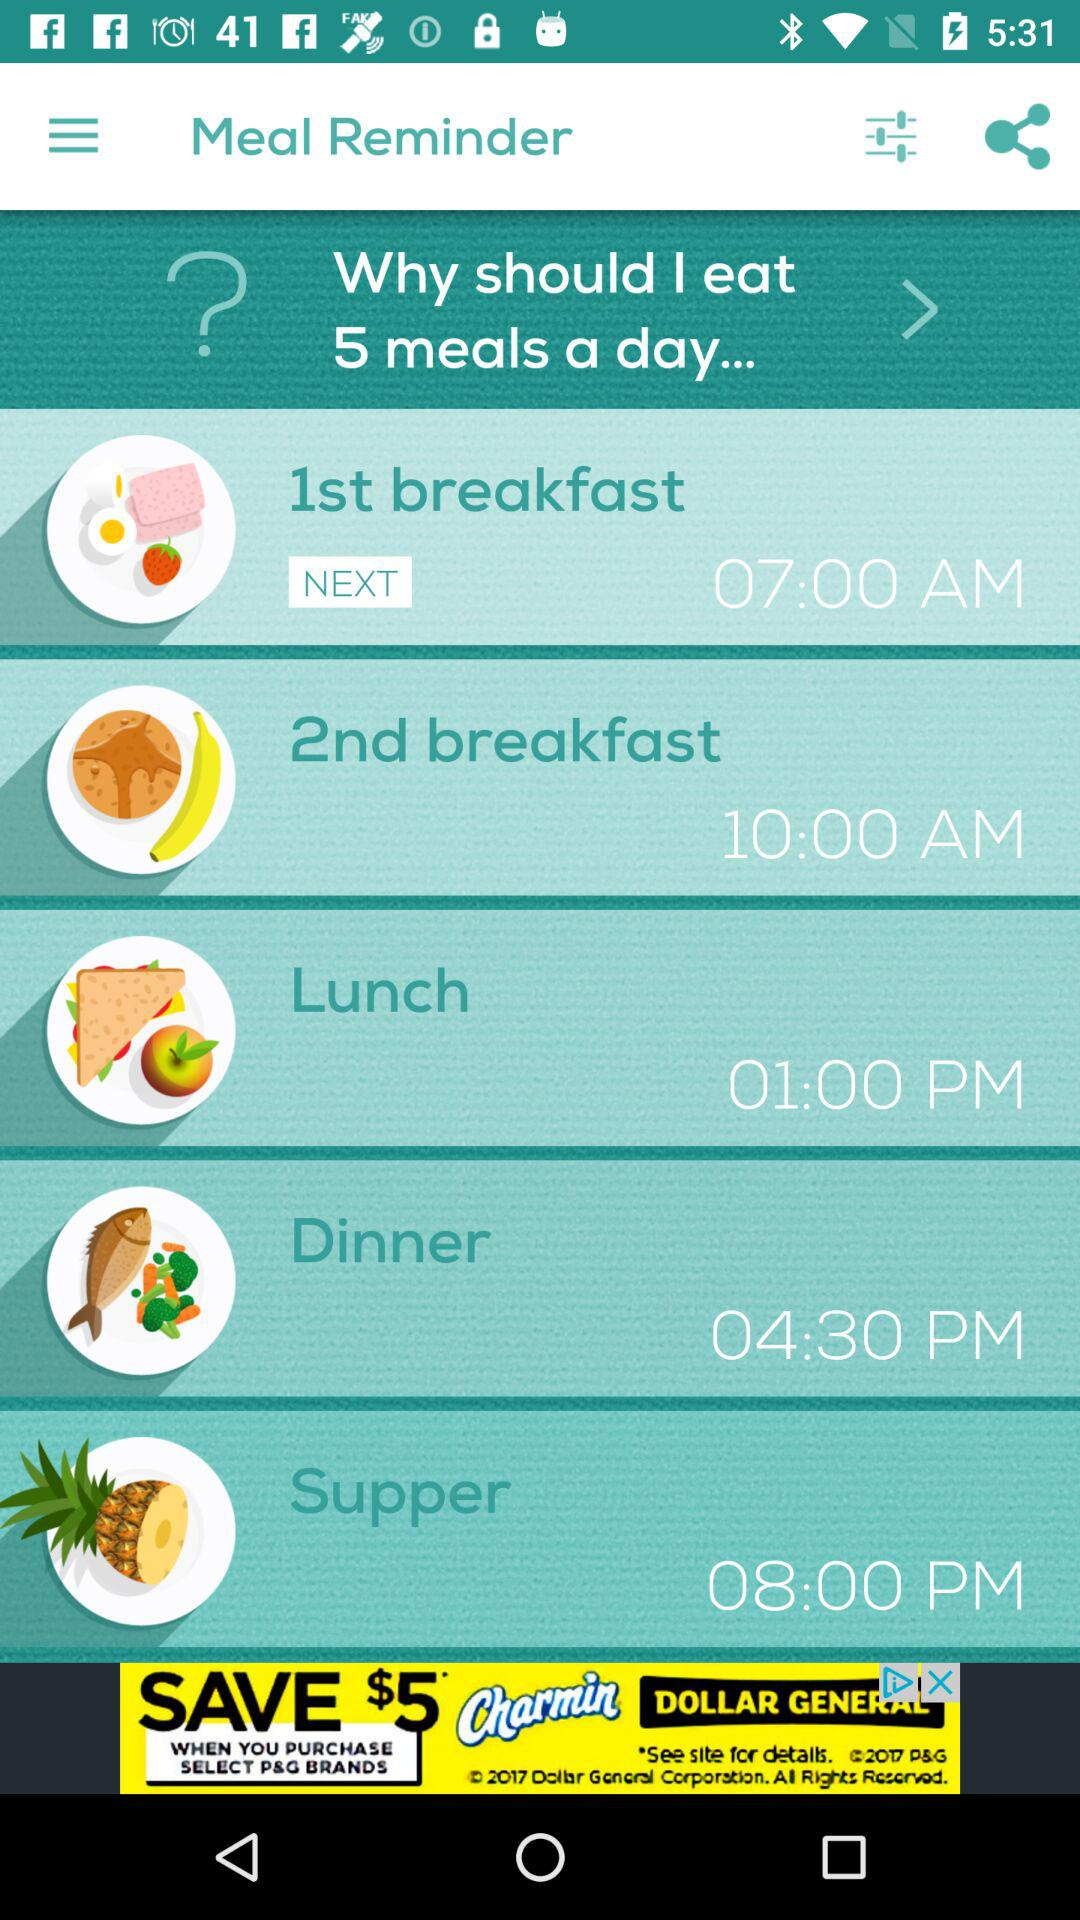How many meals are there?
Answer the question using a single word or phrase. 5 